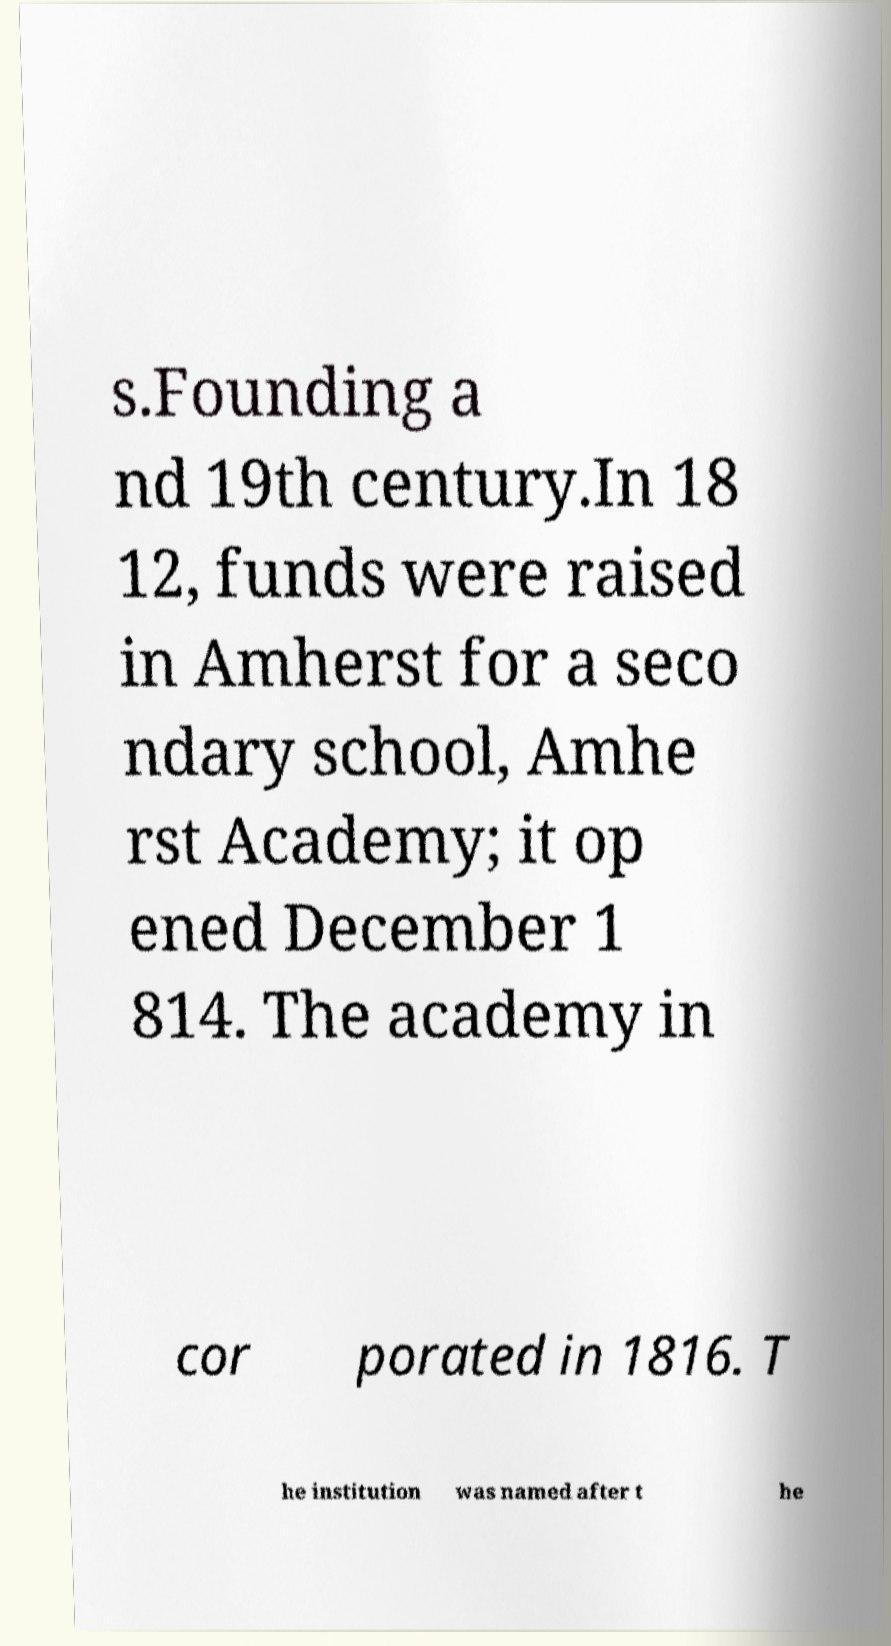There's text embedded in this image that I need extracted. Can you transcribe it verbatim? s.Founding a nd 19th century.In 18 12, funds were raised in Amherst for a seco ndary school, Amhe rst Academy; it op ened December 1 814. The academy in cor porated in 1816. T he institution was named after t he 